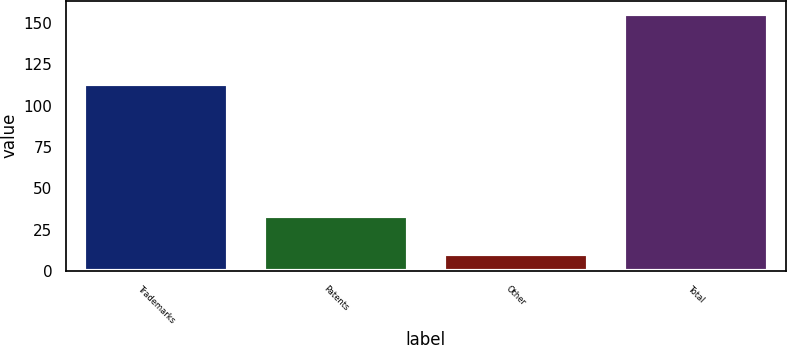Convert chart to OTSL. <chart><loc_0><loc_0><loc_500><loc_500><bar_chart><fcel>Trademarks<fcel>Patents<fcel>Other<fcel>Total<nl><fcel>113<fcel>32.9<fcel>9.9<fcel>155.8<nl></chart> 